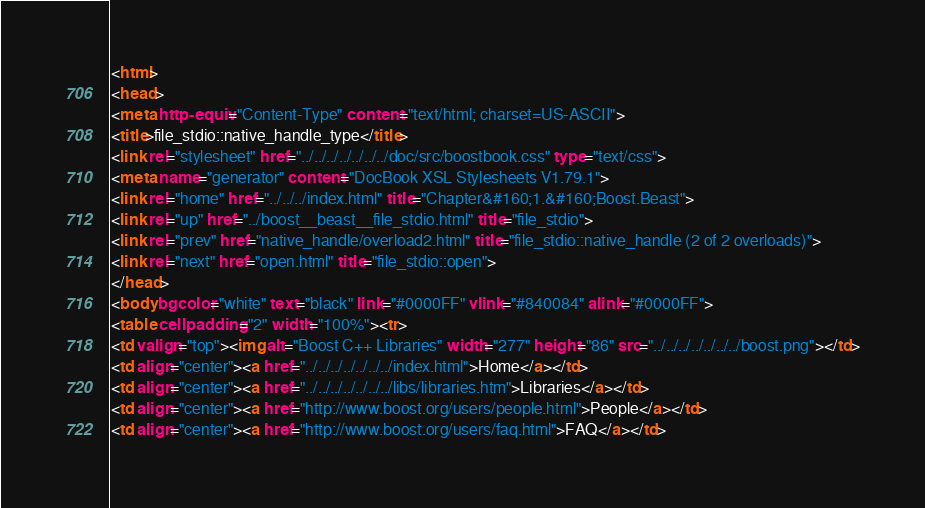Convert code to text. <code><loc_0><loc_0><loc_500><loc_500><_HTML_><html>
<head>
<meta http-equiv="Content-Type" content="text/html; charset=US-ASCII">
<title>file_stdio::native_handle_type</title>
<link rel="stylesheet" href="../../../../../../../doc/src/boostbook.css" type="text/css">
<meta name="generator" content="DocBook XSL Stylesheets V1.79.1">
<link rel="home" href="../../../index.html" title="Chapter&#160;1.&#160;Boost.Beast">
<link rel="up" href="../boost__beast__file_stdio.html" title="file_stdio">
<link rel="prev" href="native_handle/overload2.html" title="file_stdio::native_handle (2 of 2 overloads)">
<link rel="next" href="open.html" title="file_stdio::open">
</head>
<body bgcolor="white" text="black" link="#0000FF" vlink="#840084" alink="#0000FF">
<table cellpadding="2" width="100%"><tr>
<td valign="top"><img alt="Boost C++ Libraries" width="277" height="86" src="../../../../../../../boost.png"></td>
<td align="center"><a href="../../../../../../../index.html">Home</a></td>
<td align="center"><a href="../../../../../../../libs/libraries.htm">Libraries</a></td>
<td align="center"><a href="http://www.boost.org/users/people.html">People</a></td>
<td align="center"><a href="http://www.boost.org/users/faq.html">FAQ</a></td></code> 